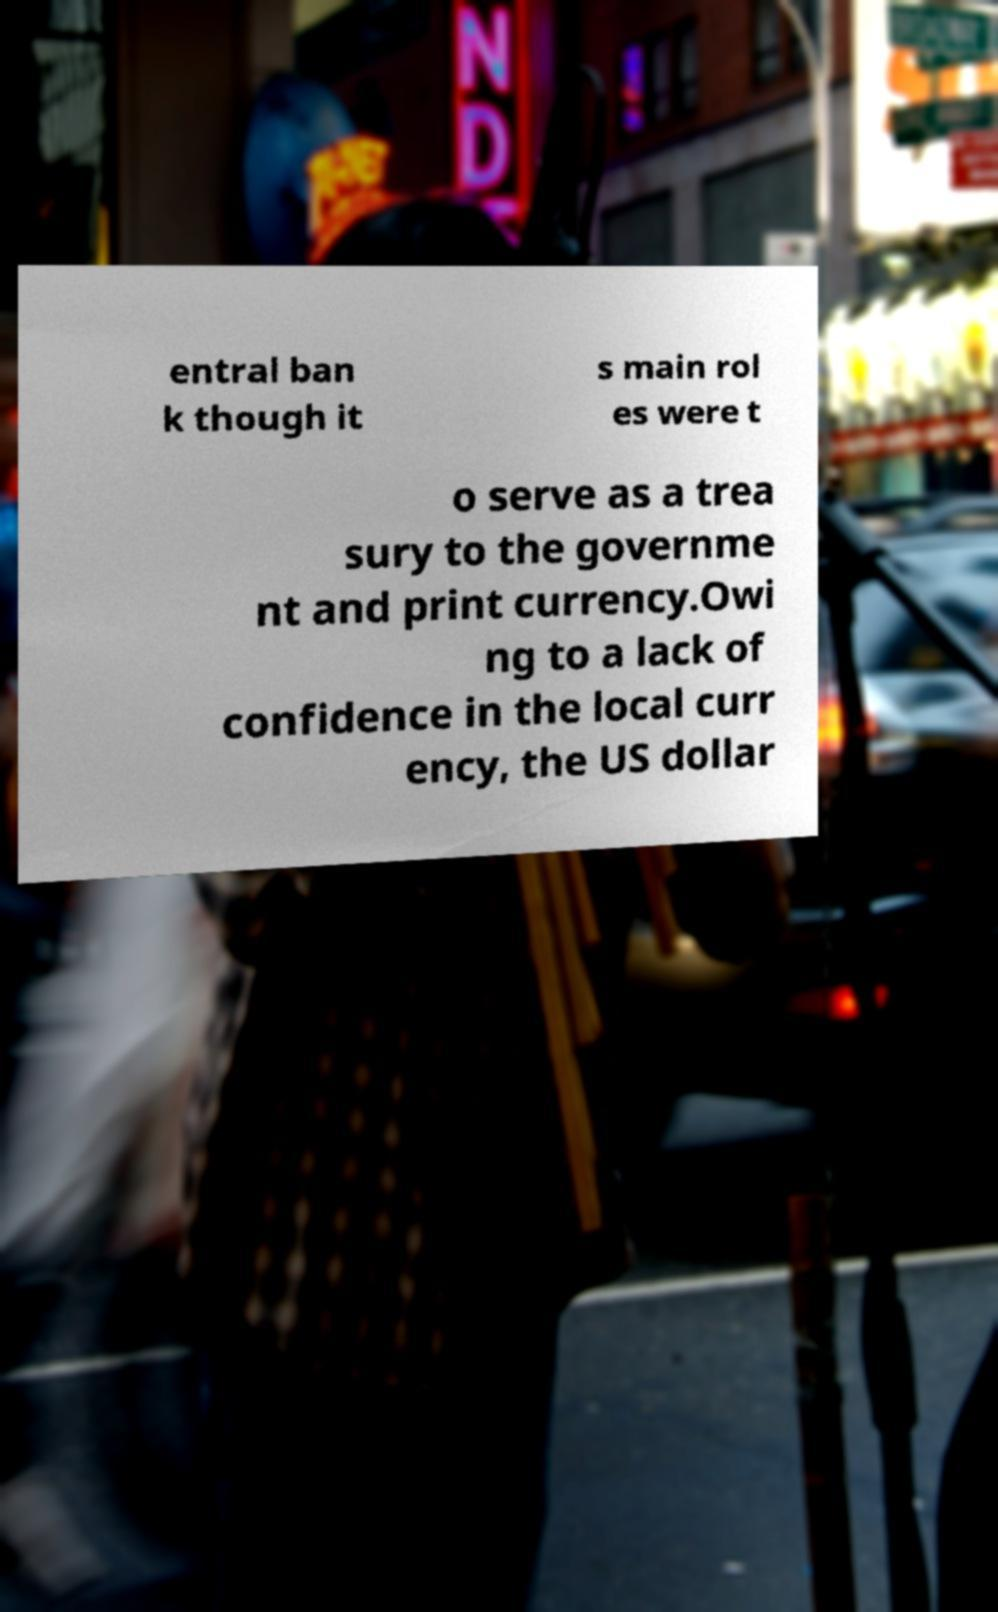Can you accurately transcribe the text from the provided image for me? entral ban k though it s main rol es were t o serve as a trea sury to the governme nt and print currency.Owi ng to a lack of confidence in the local curr ency, the US dollar 